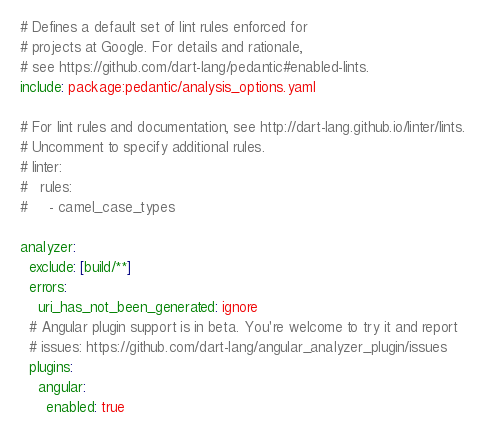Convert code to text. <code><loc_0><loc_0><loc_500><loc_500><_YAML_># Defines a default set of lint rules enforced for
# projects at Google. For details and rationale,
# see https://github.com/dart-lang/pedantic#enabled-lints.
include: package:pedantic/analysis_options.yaml

# For lint rules and documentation, see http://dart-lang.github.io/linter/lints.
# Uncomment to specify additional rules.
# linter:
#   rules:
#     - camel_case_types

analyzer:
  exclude: [build/**]
  errors:
    uri_has_not_been_generated: ignore
  # Angular plugin support is in beta. You're welcome to try it and report
  # issues: https://github.com/dart-lang/angular_analyzer_plugin/issues
  plugins:
    angular:
      enabled: true
</code> 